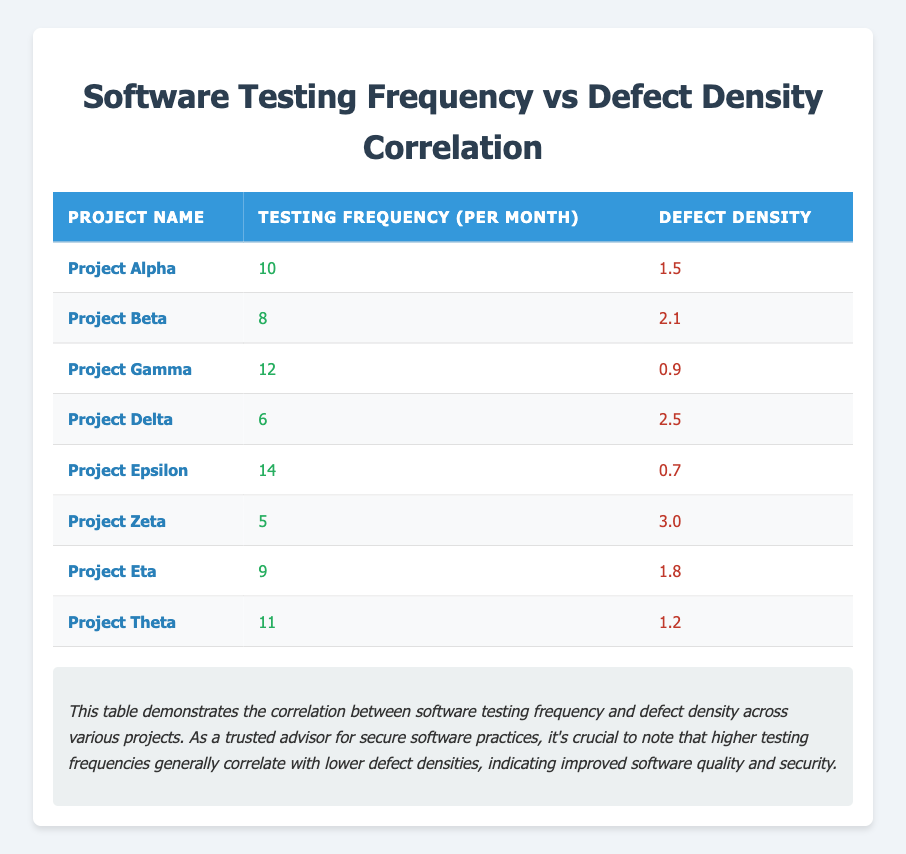What is the testing frequency of Project Epsilon? In the table, we find the row corresponding to Project Epsilon, where the testing frequency is clearly listed as 14.
Answer: 14 Which project has the highest defect density? By examining the defect density column, we observe the values: 1.5, 2.1, 0.9, 2.5, 0.7, 3.0, 1.8, and 1.2. The highest value is 3.0, which belongs to Project Zeta.
Answer: Project Zeta What is the average testing frequency of all projects? To find the average testing frequency, we first sum the frequencies: 10 + 8 + 12 + 6 + 14 + 5 + 9 + 11 = 75. There are 8 projects, so the average is 75 divided by 8, which equals 9.375.
Answer: 9.375 Is it true that Project Theta has a higher defect density than Project Alpha? Project Theta has a defect density of 1.2, while Project Alpha has a defect density of 1.5. Since 1.2 is less than 1.5, the statement is false.
Answer: No Which projects have a testing frequency of 10 or more and what are their defect densities? We filter the projects with testing frequencies of 10 or more: Project Alpha (1.5), Project Gamma (0.9), Project Epsilon (0.7), Project Theta (1.2), and Project Zeta (3.0). The corresponding defect densities are 1.5, 0.9, 0.7, and 1.2.
Answer: Project Alpha: 1.5, Project Gamma: 0.9, Project Epsilon: 0.7, Project Theta: 1.2 What is the total defect density of projects with a testing frequency less than 8? The projects with testing frequencies less than 8 are Project Delta (2.5) and Project Zeta (3.0). Summing these gives 2.5 + 3.0 = 5.5.
Answer: 5.5 Is it true that higher testing frequency is associated with a lower defect density in this data? By analyzing the data, we can observe that as the testing frequency increases, the defect density tends to decrease. For instance, Project Epsilon with the highest frequency (14) has the lowest defect density (0.7), which supports the trend. Thus, the statement is true.
Answer: Yes What is the difference in defect density between Project Beta and Project Delta? To find the difference, we subtract the defect density of Project Delta (2.5) from that of Project Beta (2.1): 2.1 - 2.5 = -0.4. This indicates that Project Beta has a lower defect density.
Answer: -0.4 